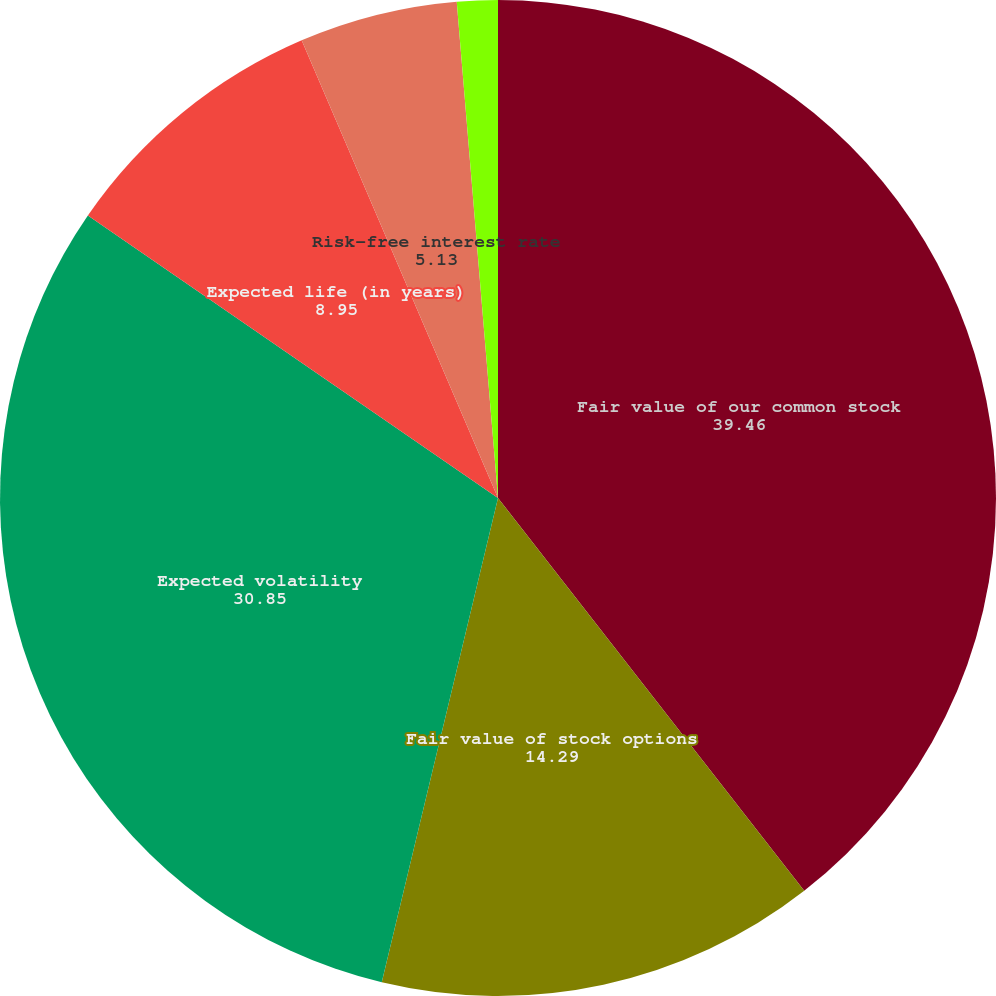<chart> <loc_0><loc_0><loc_500><loc_500><pie_chart><fcel>Fair value of our common stock<fcel>Fair value of stock options<fcel>Expected volatility<fcel>Expected life (in years)<fcel>Risk-free interest rate<fcel>Expected dividend yield<nl><fcel>39.46%<fcel>14.29%<fcel>30.85%<fcel>8.95%<fcel>5.13%<fcel>1.32%<nl></chart> 